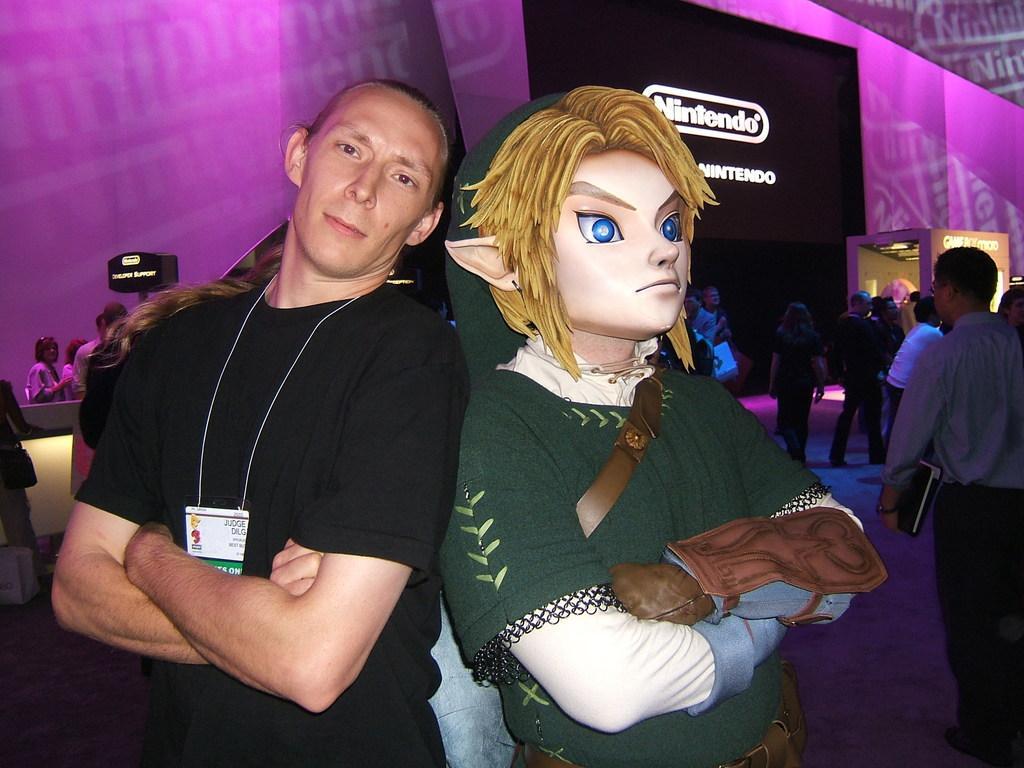Please provide a concise description of this image. In the center of the image we can see two persons standing. One person is wearing costume and a mask. In the background of the image we can see a group of people standing on the floor. One person is holding a book in his hand, a screen and a sign board with some text on it. 